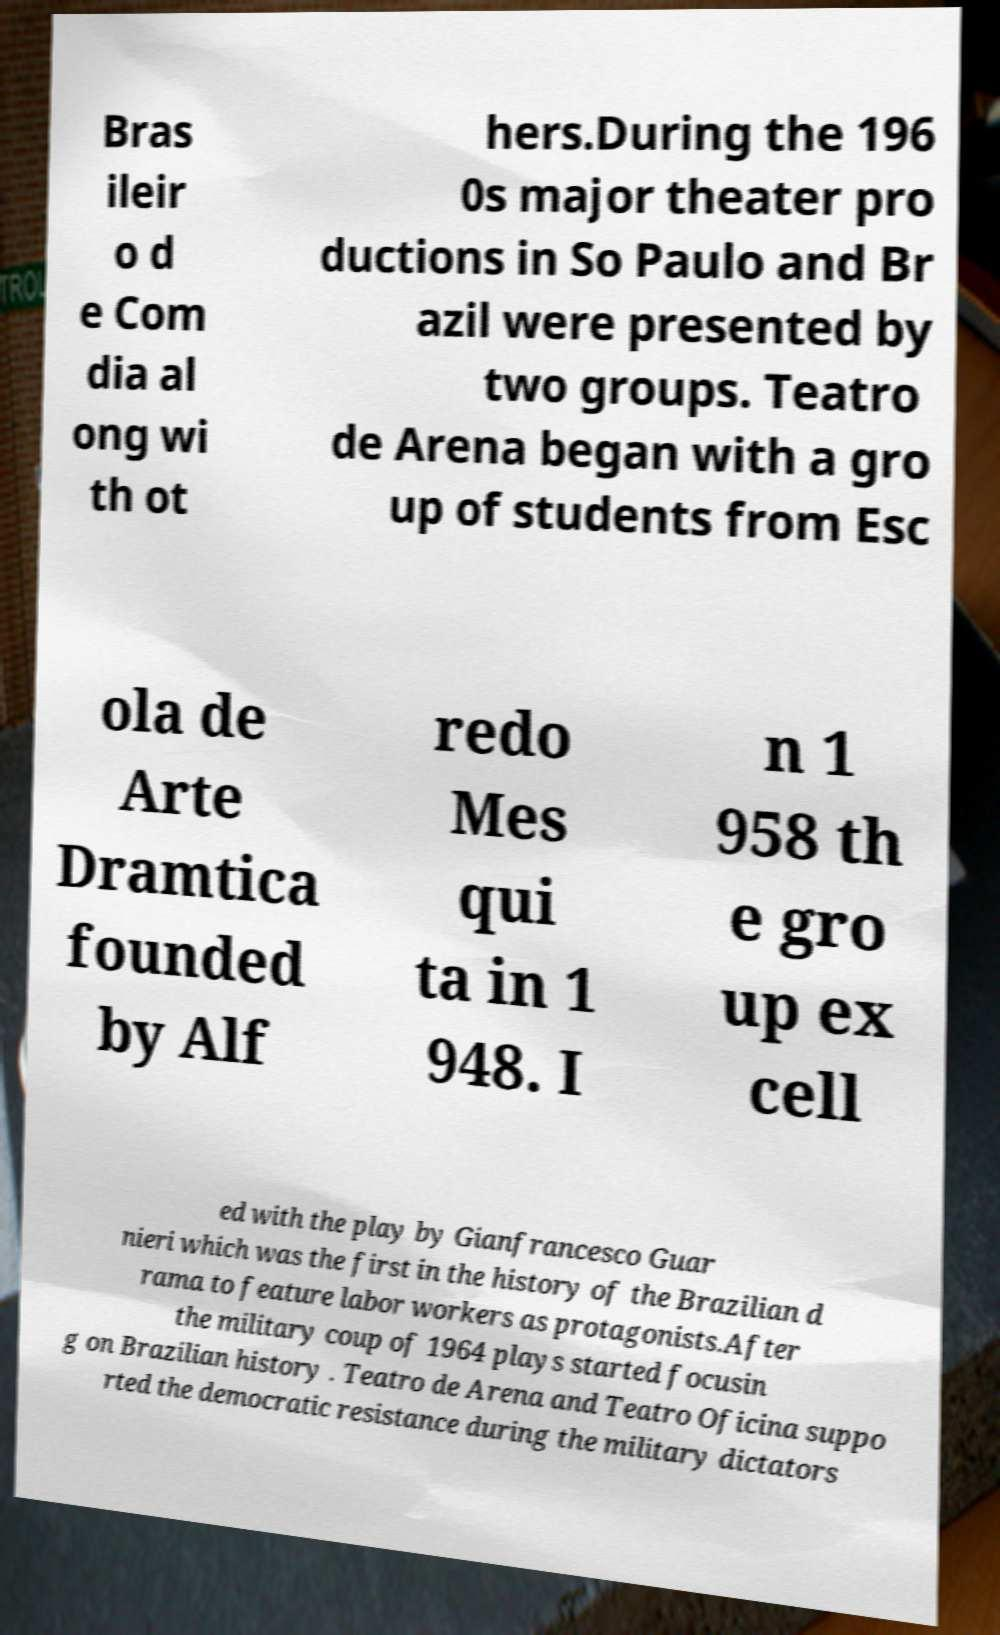For documentation purposes, I need the text within this image transcribed. Could you provide that? Bras ileir o d e Com dia al ong wi th ot hers.During the 196 0s major theater pro ductions in So Paulo and Br azil were presented by two groups. Teatro de Arena began with a gro up of students from Esc ola de Arte Dramtica founded by Alf redo Mes qui ta in 1 948. I n 1 958 th e gro up ex cell ed with the play by Gianfrancesco Guar nieri which was the first in the history of the Brazilian d rama to feature labor workers as protagonists.After the military coup of 1964 plays started focusin g on Brazilian history . Teatro de Arena and Teatro Oficina suppo rted the democratic resistance during the military dictators 